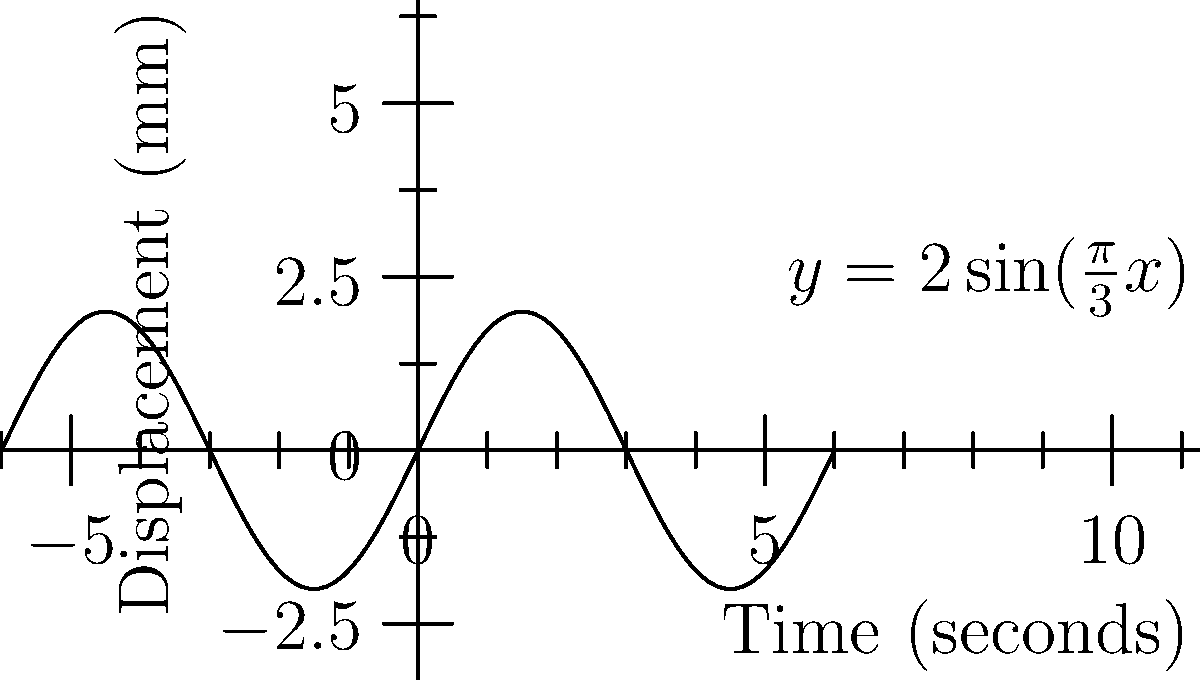The vibration of a vintage typewriter's ribbon during typing can be modeled by the sine function $y = 2\sin(\frac{\pi}{3}x)$, where $y$ represents the displacement in millimeters and $x$ represents time in seconds. Determine the period and amplitude of this sine curve. To find the period and amplitude of the given sine function $y = 2\sin(\frac{\pi}{3}x)$, we need to compare it to the standard form of a sine function:

$y = A\sin(Bx)$, where:
- $A$ is the amplitude
- $\frac{2\pi}{B}$ is the period

Step 1: Identify the amplitude
The amplitude is the coefficient in front of the sine function. In this case, $A = 2$.

Step 2: Identify $B$
In our function, $\frac{\pi}{3}x$ is inside the sine function. So, $B = \frac{\pi}{3}$.

Step 3: Calculate the period
The period is given by $\frac{2\pi}{B}$. 
Period $= \frac{2\pi}{\frac{\pi}{3}} = \frac{2\pi}{\pi} \cdot 3 = 6$ seconds.

Therefore, the amplitude is 2 mm, and the period is 6 seconds.
Answer: Amplitude: 2 mm, Period: 6 seconds 